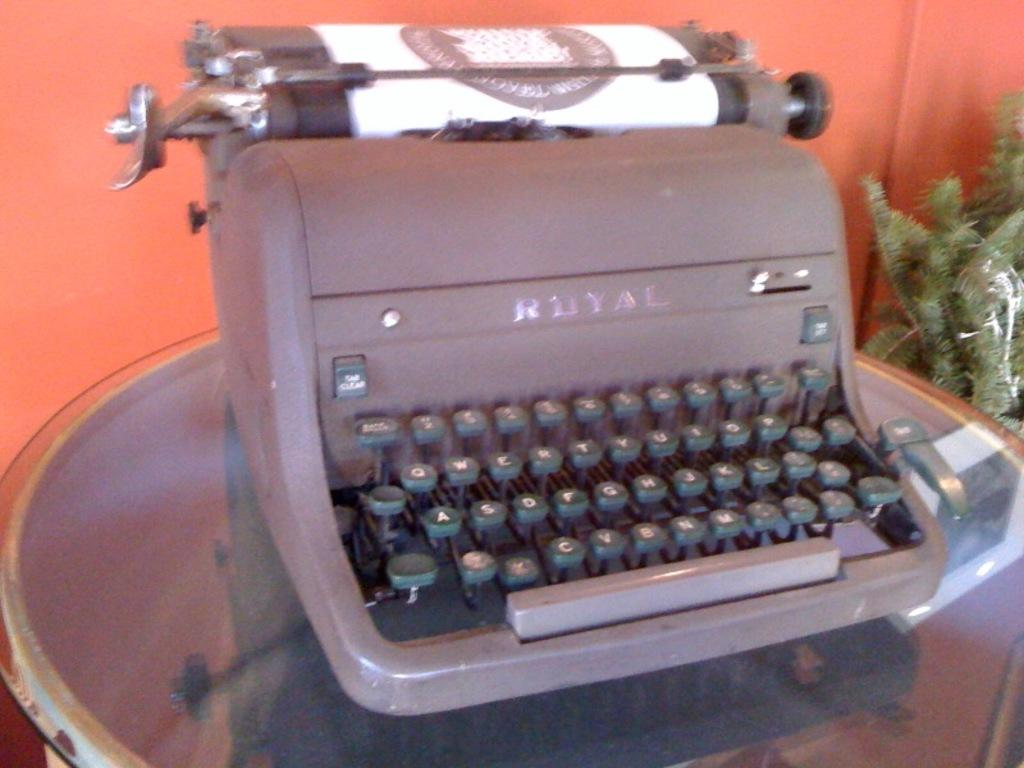<image>
Provide a brief description of the given image. An antique manual Royal typewriter with a piece of paper in it. 